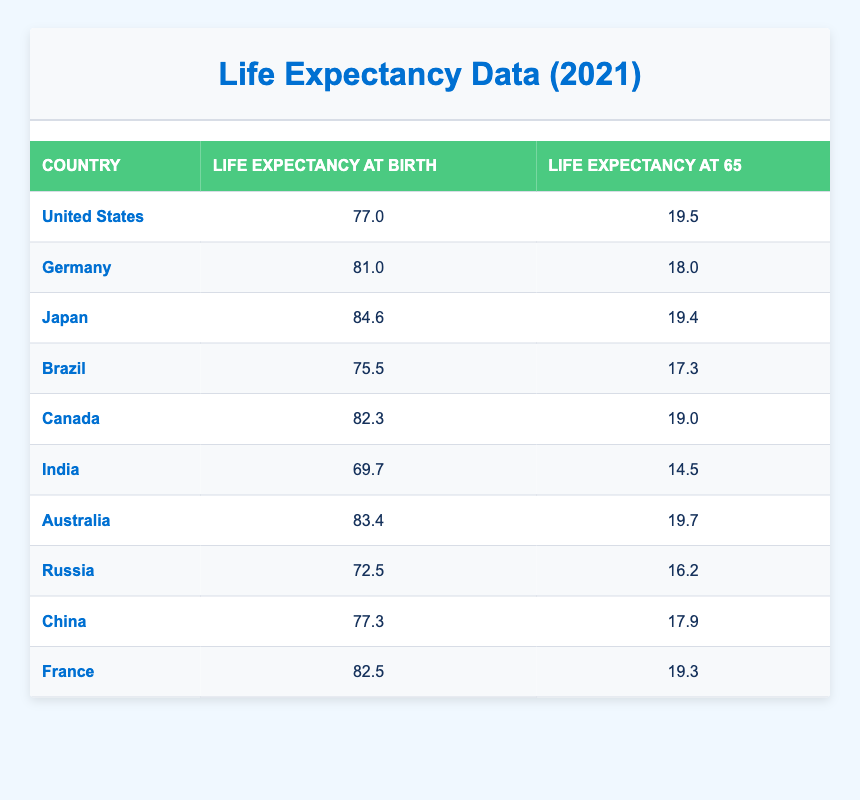What is the life expectancy at birth in Japan? The life expectancy at birth in Japan is listed in the table as 84.6 years.
Answer: 84.6 Which country has the highest life expectancy at 65 years? By examining the life expectancy at 65 years across all countries in the table, Australia has the highest value at 19.7 years.
Answer: Australia What is the average life expectancy at birth of the countries listed? To find the average, we sum the life expectancies at birth: (77.0 + 81.0 + 84.6 + 75.5 + 82.3 + 69.7 + 83.4 + 72.5 + 77.3 + 82.5) =  810.4. Then we divide that sum by the number of countries (10): 810.4 / 10 = 81.04.
Answer: 81.04 Is the life expectancy at 65 years in Brazil greater than in China? The life expectancy at 65 years in Brazil is 17.3, while in China it is 17.9. Since 17.3 is less than 17.9, the statement is false.
Answer: No What is the difference in life expectancy at birth between the United States and India? The life expectancy at birth for the United States is 77.0 and for India it is 69.7. The difference is 77.0 - 69.7 = 7.3 years.
Answer: 7.3 How many countries have a life expectancy at 65 years greater than 19 years? By checking the entries in the 65 years column, Australia (19.7), Japan (19.4), Canada (19.0), France (19.3), and United States (19.5) all have values around or just above 19, totaling five countries.
Answer: 5 Is there a country where life expectancy at birth is below 70 years? Looking through the life expectancy at birth data, we see that India has a value of 69.7, which is below 70 years, making the statement true.
Answer: Yes Which country has the lowest life expectancy at birth? Upon reviewing the data in the table, India has the lowest life expectancy at birth at 69.7 years, compared to all other listed countries.
Answer: India 